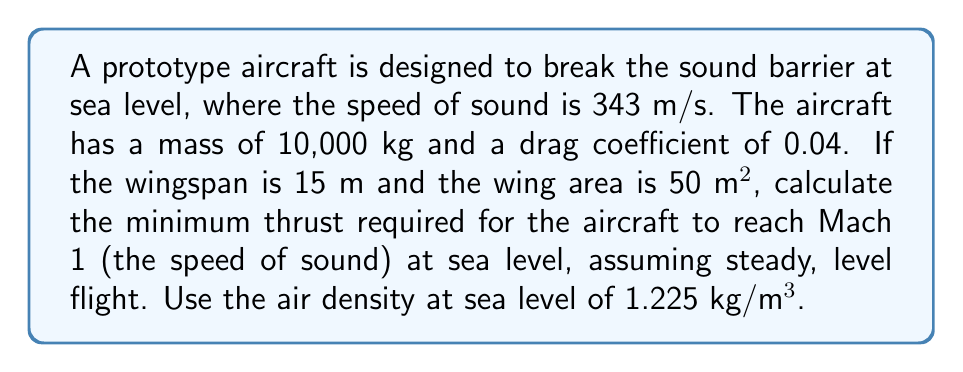Give your solution to this math problem. To solve this problem, we need to follow these steps:

1. Calculate the velocity at Mach 1:
   $$v = \text{Mach} \times \text{speed of sound} = 1 \times 343 \text{ m/s} = 343 \text{ m/s}$$

2. Calculate the dynamic pressure:
   $$q = \frac{1}{2} \rho v^2 = \frac{1}{2} \times 1.225 \times 343^2 = 72,054.71 \text{ Pa}$$

3. Calculate the drag force using the drag equation:
   $$F_D = C_D \times q \times S$$
   Where $C_D$ is the drag coefficient, $q$ is the dynamic pressure, and $S$ is the wing area.
   $$F_D = 0.04 \times 72,054.71 \times 50 = 144,109.42 \text{ N}$$

4. In steady, level flight, the thrust must equal the drag force. Therefore, the minimum thrust required is:
   $$T = F_D = 144,109.42 \text{ N}$$

5. Convert to kilonewtons for a more practical unit:
   $$T = 144.11 \text{ kN}$$
Answer: 144.11 kN 